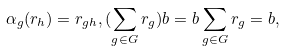<formula> <loc_0><loc_0><loc_500><loc_500>\alpha _ { g } ( r _ { h } ) = r _ { g h } , ( \sum _ { g \in G } r _ { g } ) b = b \sum _ { g \in G } r _ { g } = b ,</formula> 